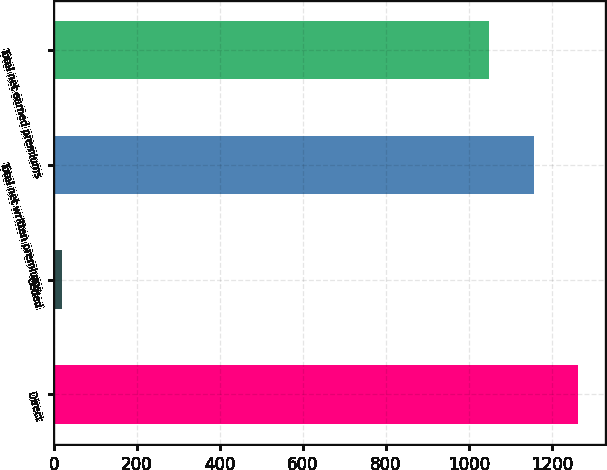Convert chart to OTSL. <chart><loc_0><loc_0><loc_500><loc_500><bar_chart><fcel>Direct<fcel>Ceded<fcel>Total net written premiums<fcel>Total net earned premiums<nl><fcel>1263.8<fcel>19<fcel>1156.4<fcel>1049<nl></chart> 